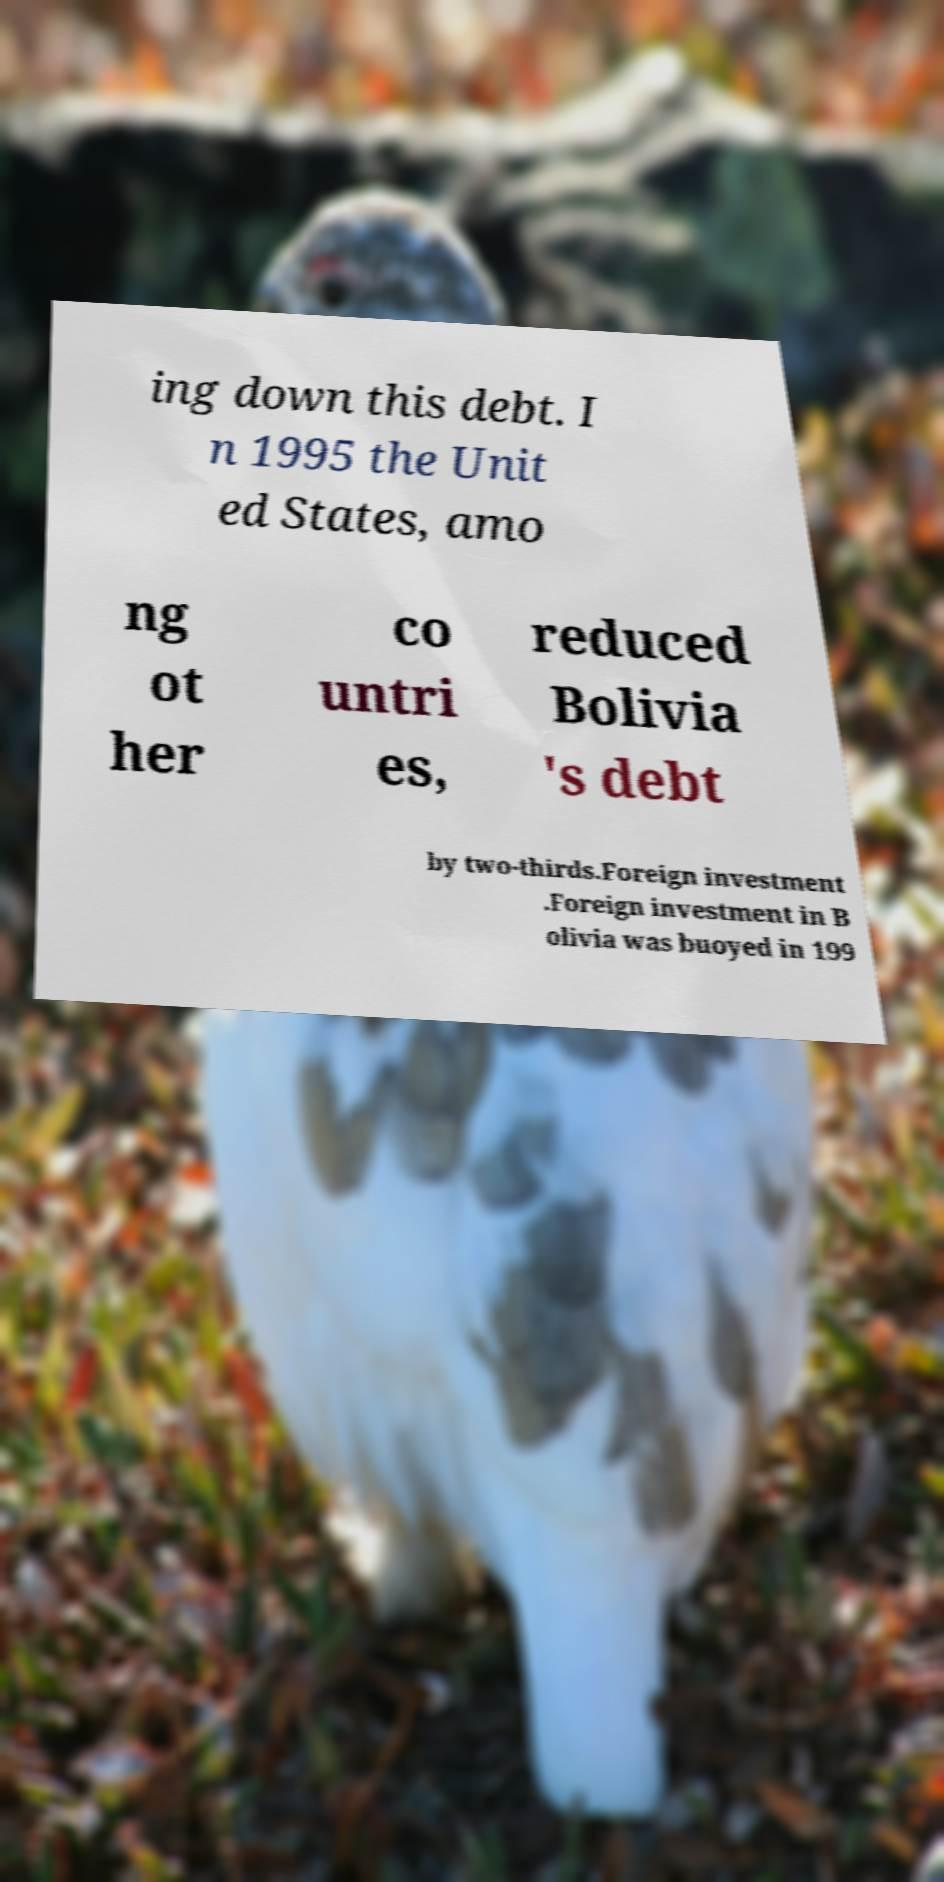Can you read and provide the text displayed in the image?This photo seems to have some interesting text. Can you extract and type it out for me? ing down this debt. I n 1995 the Unit ed States, amo ng ot her co untri es, reduced Bolivia 's debt by two-thirds.Foreign investment .Foreign investment in B olivia was buoyed in 199 